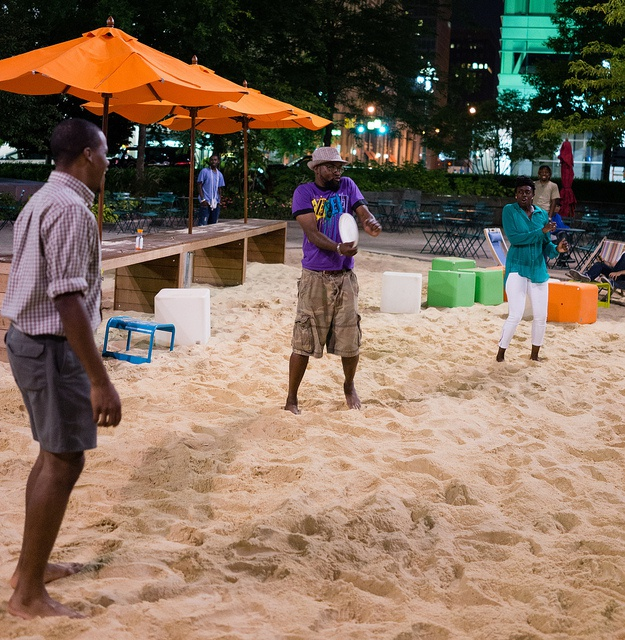Describe the objects in this image and their specific colors. I can see people in black, maroon, gray, and darkgray tones, people in black, gray, maroon, and brown tones, umbrella in black, red, orange, and brown tones, dining table in black, maroon, and gray tones, and people in black, teal, and lavender tones in this image. 